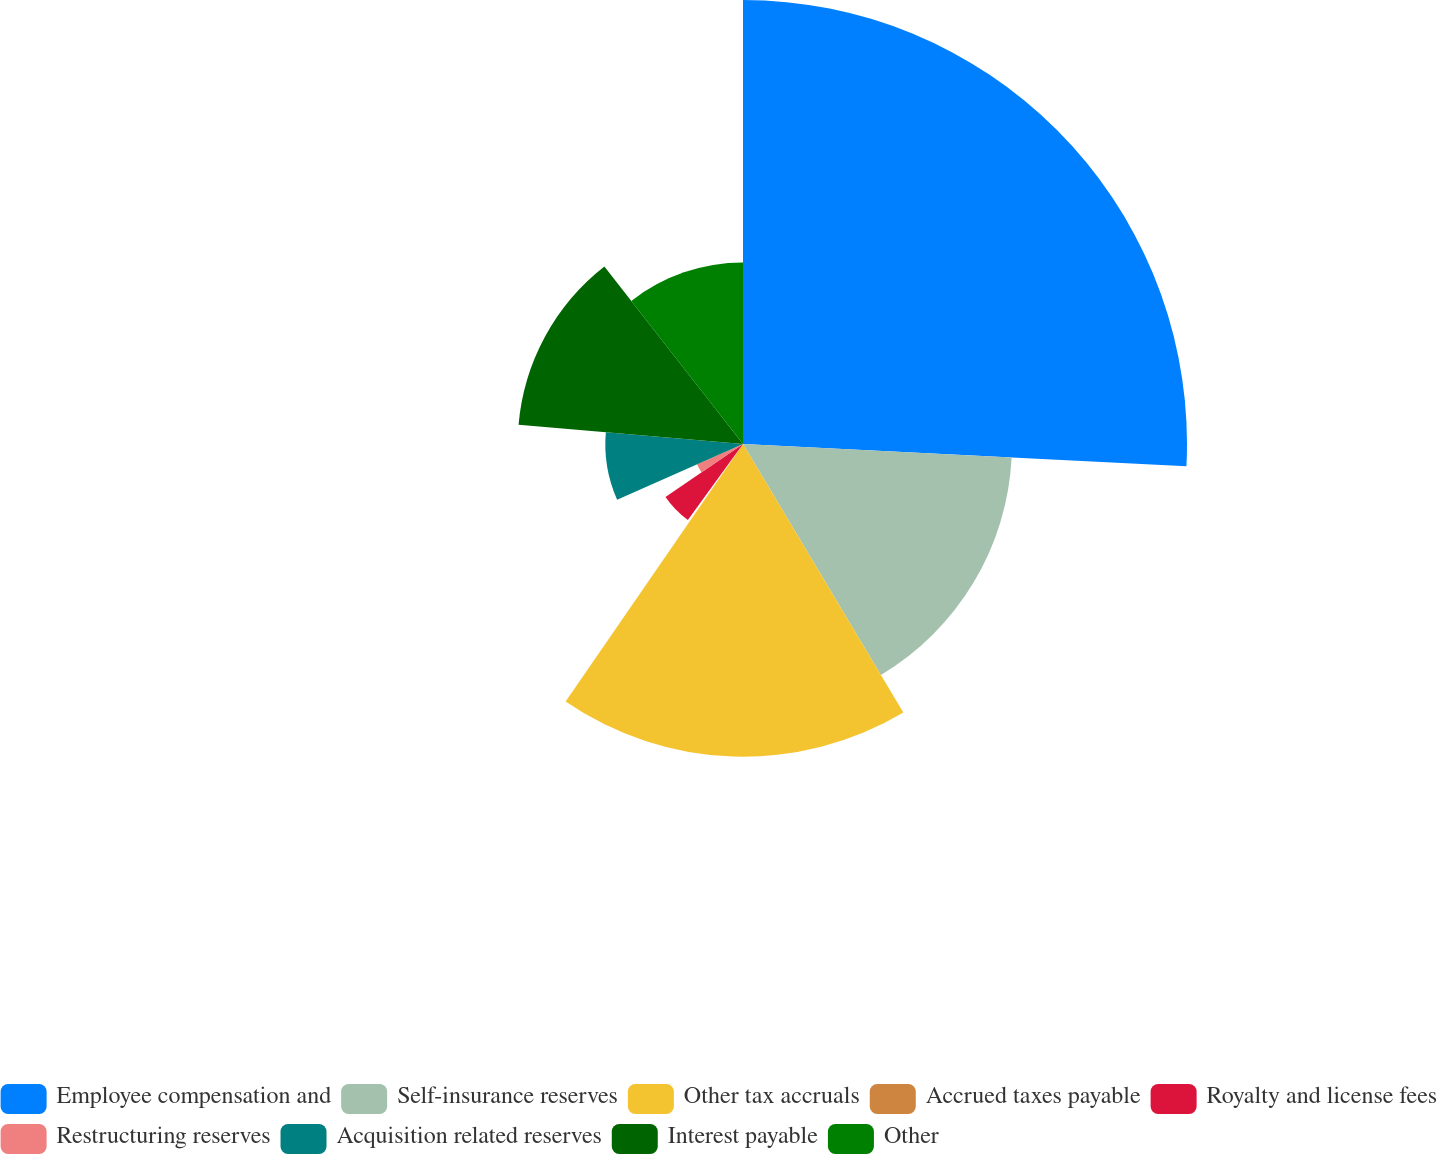Convert chart. <chart><loc_0><loc_0><loc_500><loc_500><pie_chart><fcel>Employee compensation and<fcel>Self-insurance reserves<fcel>Other tax accruals<fcel>Accrued taxes payable<fcel>Royalty and license fees<fcel>Restructuring reserves<fcel>Acquisition related reserves<fcel>Interest payable<fcel>Other<nl><fcel>25.8%<fcel>15.63%<fcel>18.17%<fcel>0.38%<fcel>5.46%<fcel>2.92%<fcel>8.0%<fcel>13.09%<fcel>10.55%<nl></chart> 